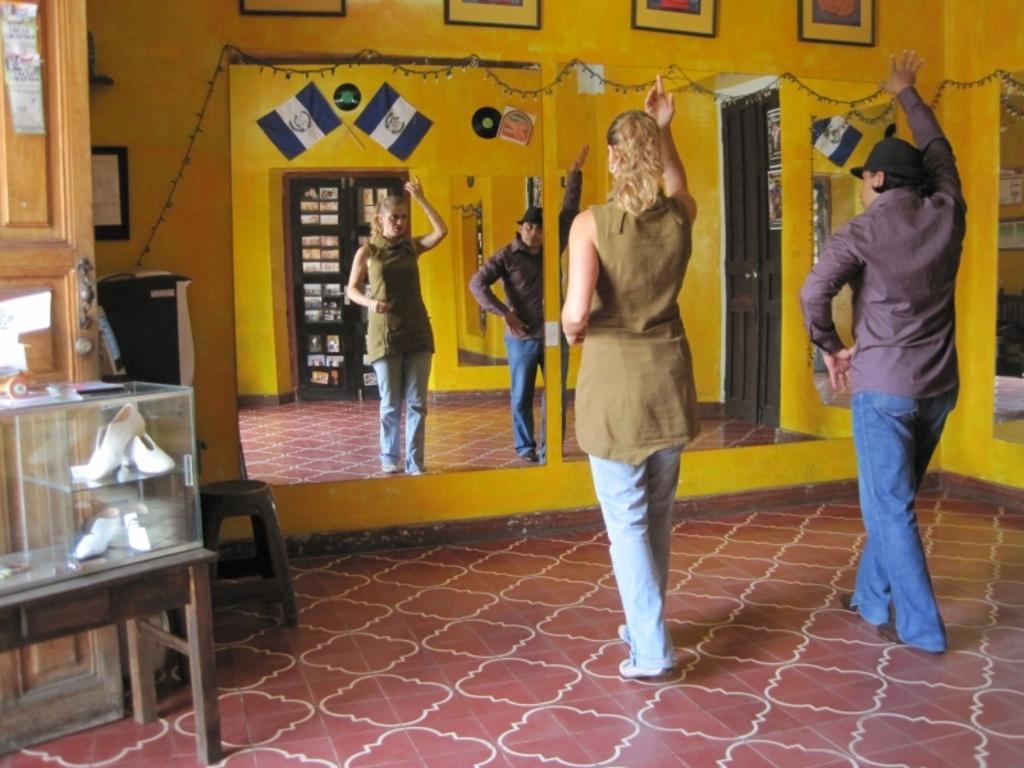How would you summarize this image in a sentence or two? In this image, there are a few people. We can see the ground. We can see a glass container with some objects on a table. We can see a stool and some wood. We can also see the wall with some frames. We can see some lights. We can see the mirror with some objects. We can also see the reflection of people and the doors in the mirror. 